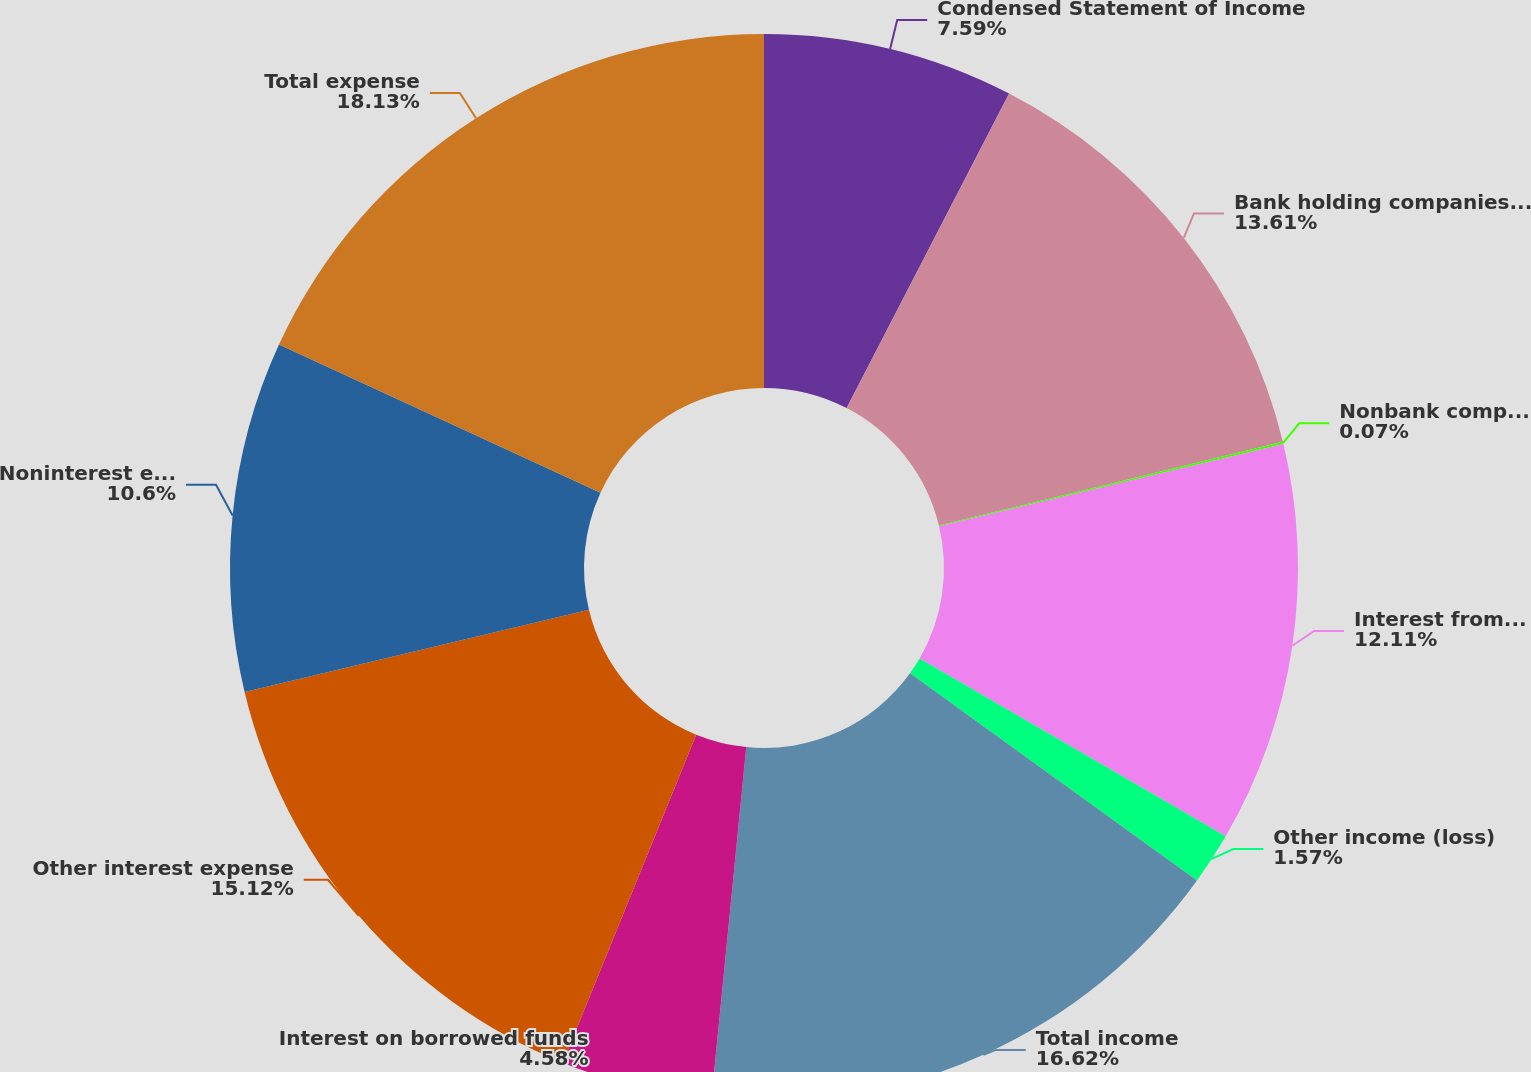Convert chart to OTSL. <chart><loc_0><loc_0><loc_500><loc_500><pie_chart><fcel>Condensed Statement of Income<fcel>Bank holding companies and<fcel>Nonbank companies and related<fcel>Interest from subsidiaries<fcel>Other income (loss)<fcel>Total income<fcel>Interest on borrowed funds<fcel>Other interest expense<fcel>Noninterest expense<fcel>Total expense<nl><fcel>7.59%<fcel>13.61%<fcel>0.07%<fcel>12.11%<fcel>1.57%<fcel>16.62%<fcel>4.58%<fcel>15.12%<fcel>10.6%<fcel>18.13%<nl></chart> 